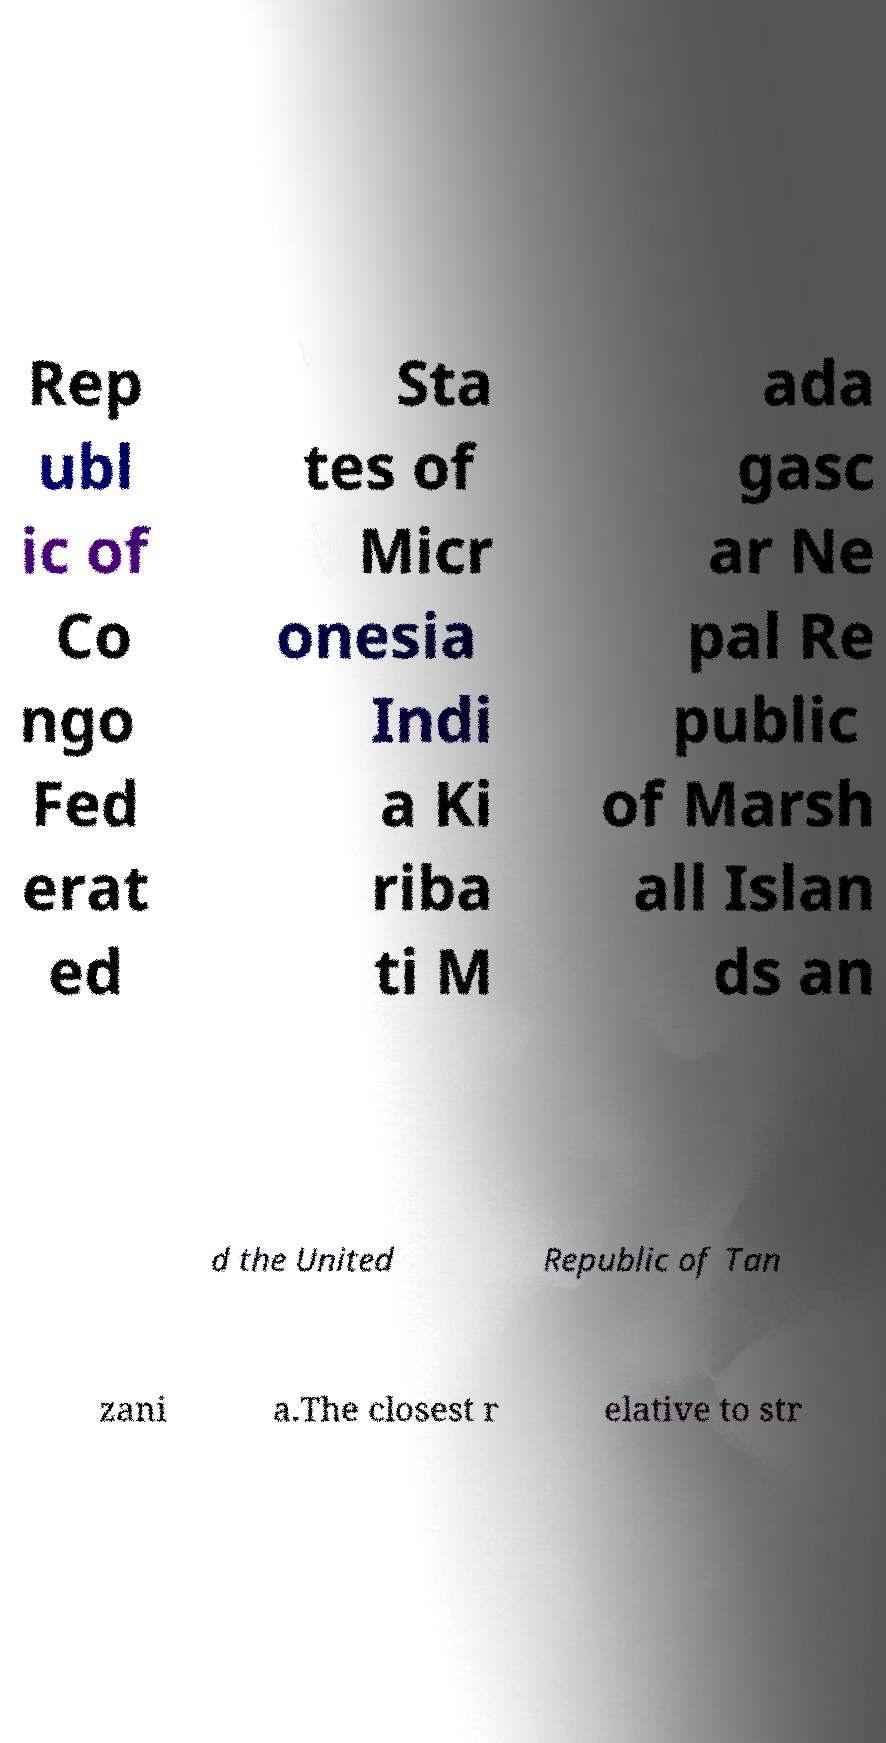Can you read and provide the text displayed in the image?This photo seems to have some interesting text. Can you extract and type it out for me? Rep ubl ic of Co ngo Fed erat ed Sta tes of Micr onesia Indi a Ki riba ti M ada gasc ar Ne pal Re public of Marsh all Islan ds an d the United Republic of Tan zani a.The closest r elative to str 